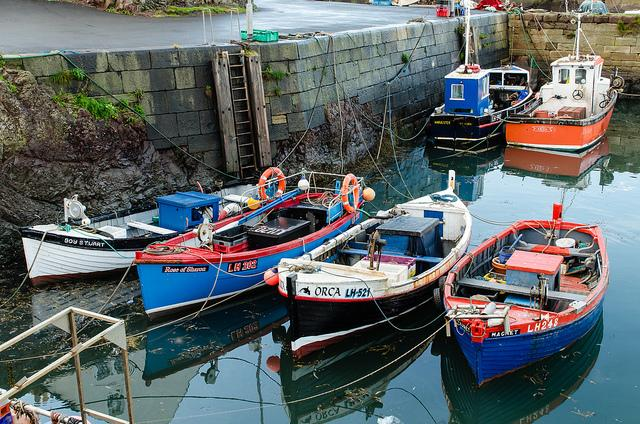What is available to get from the boats to the ground level?

Choices:
A) rope
B) stairs
C) ladder
D) elevator ladder 